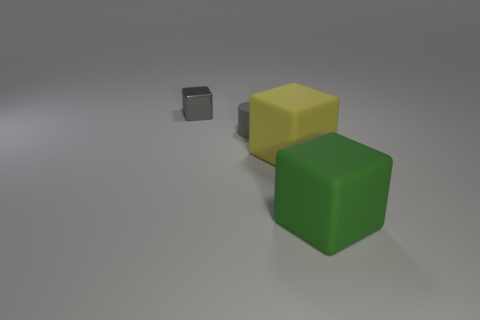Subtract all matte cubes. How many cubes are left? 1 Add 4 large green matte objects. How many objects exist? 8 Subtract all gray blocks. How many blocks are left? 2 Subtract all cylinders. How many objects are left? 3 Subtract 1 cylinders. How many cylinders are left? 0 Subtract all gray things. Subtract all metallic objects. How many objects are left? 1 Add 1 tiny gray shiny blocks. How many tiny gray shiny blocks are left? 2 Add 2 tiny blocks. How many tiny blocks exist? 3 Subtract 1 gray blocks. How many objects are left? 3 Subtract all cyan blocks. Subtract all yellow cylinders. How many blocks are left? 3 